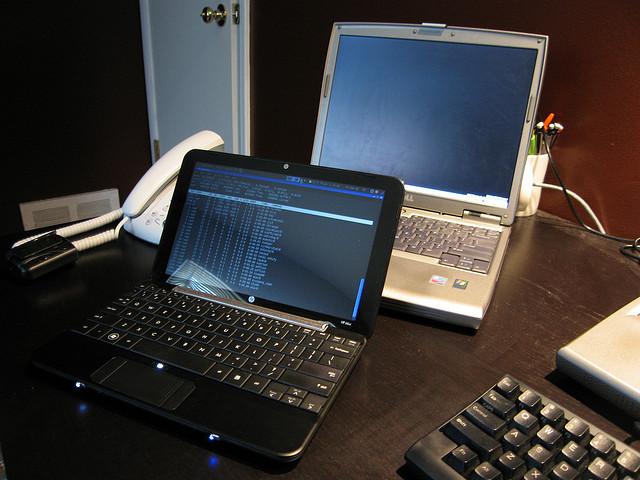Are these laptops used for fun or work?
Concise answer only. Work. How many keyboards are in the picture?
Write a very short answer. 3. Is the phone off the hook?
Short answer required. No. 